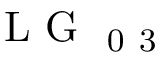<formula> <loc_0><loc_0><loc_500><loc_500>L G _ { 0 3 }</formula> 